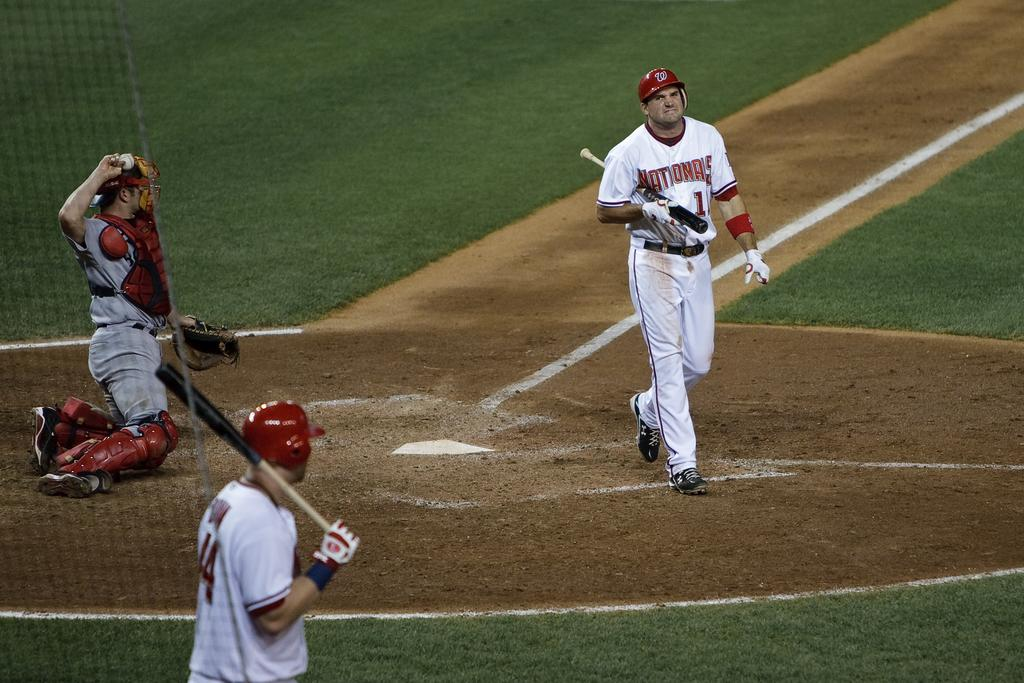<image>
Write a terse but informative summary of the picture. a player with a Nationals jersey on walking 